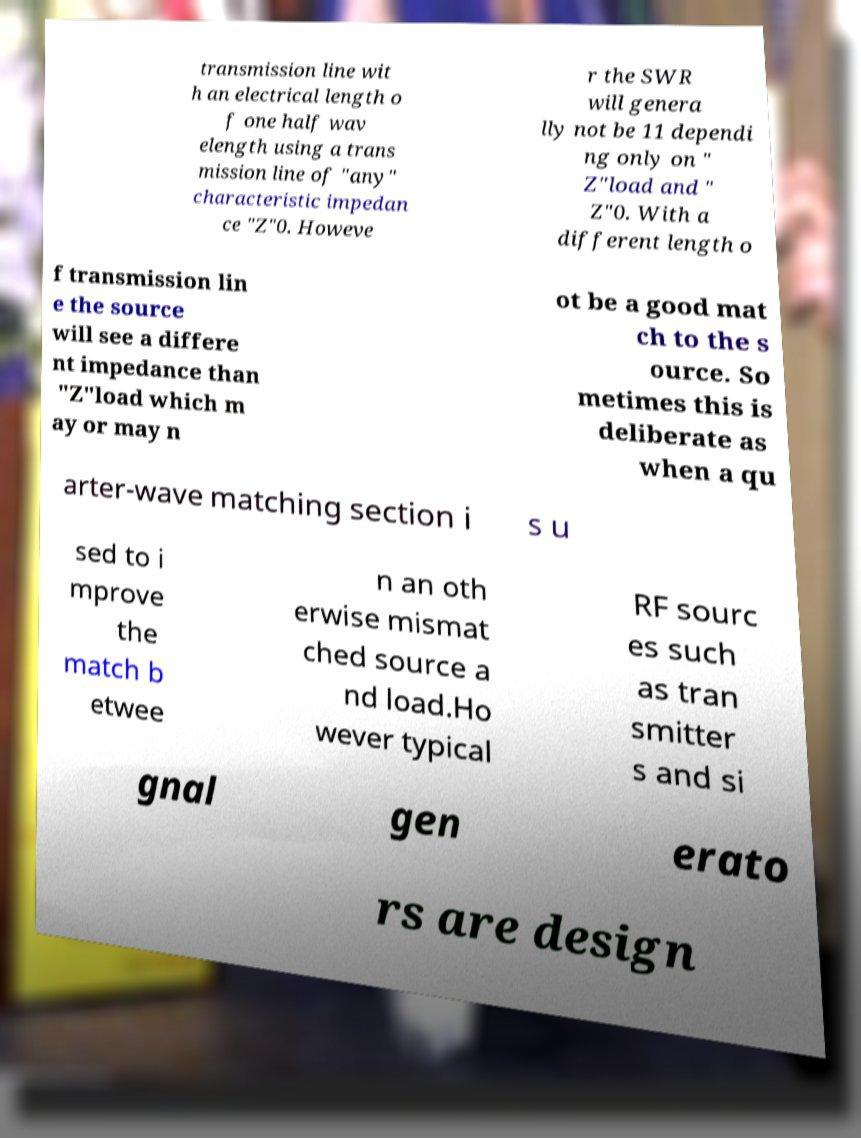Can you accurately transcribe the text from the provided image for me? transmission line wit h an electrical length o f one half wav elength using a trans mission line of "any" characteristic impedan ce "Z"0. Howeve r the SWR will genera lly not be 11 dependi ng only on " Z"load and " Z"0. With a different length o f transmission lin e the source will see a differe nt impedance than "Z"load which m ay or may n ot be a good mat ch to the s ource. So metimes this is deliberate as when a qu arter-wave matching section i s u sed to i mprove the match b etwee n an oth erwise mismat ched source a nd load.Ho wever typical RF sourc es such as tran smitter s and si gnal gen erato rs are design 